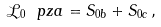<formula> <loc_0><loc_0><loc_500><loc_500>\mathcal { L } _ { 0 } \ p z a = S _ { 0 b } + S _ { 0 c } \, ,</formula> 